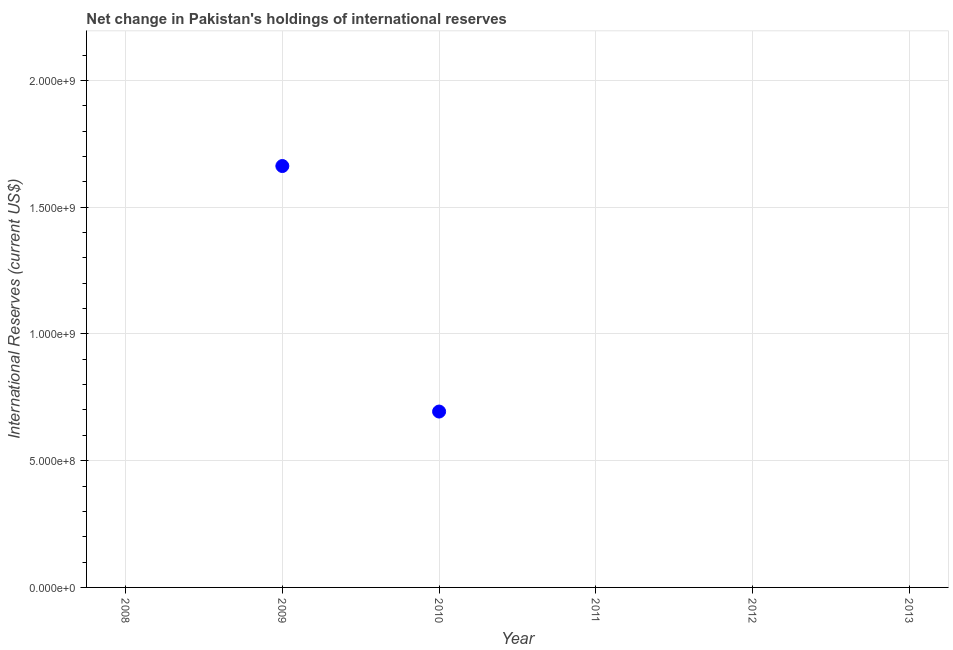What is the reserves and related items in 2009?
Provide a succinct answer. 1.66e+09. Across all years, what is the maximum reserves and related items?
Provide a short and direct response. 1.66e+09. What is the sum of the reserves and related items?
Offer a very short reply. 2.36e+09. What is the average reserves and related items per year?
Offer a very short reply. 3.93e+08. What is the median reserves and related items?
Your answer should be compact. 0. Is the reserves and related items in 2009 less than that in 2010?
Provide a succinct answer. No. What is the difference between the highest and the lowest reserves and related items?
Your response must be concise. 1.66e+09. How many years are there in the graph?
Offer a terse response. 6. Are the values on the major ticks of Y-axis written in scientific E-notation?
Provide a short and direct response. Yes. Does the graph contain any zero values?
Provide a short and direct response. Yes. What is the title of the graph?
Your answer should be very brief. Net change in Pakistan's holdings of international reserves. What is the label or title of the X-axis?
Your response must be concise. Year. What is the label or title of the Y-axis?
Your answer should be compact. International Reserves (current US$). What is the International Reserves (current US$) in 2008?
Your answer should be very brief. 0. What is the International Reserves (current US$) in 2009?
Make the answer very short. 1.66e+09. What is the International Reserves (current US$) in 2010?
Your answer should be very brief. 6.94e+08. What is the difference between the International Reserves (current US$) in 2009 and 2010?
Make the answer very short. 9.69e+08. What is the ratio of the International Reserves (current US$) in 2009 to that in 2010?
Ensure brevity in your answer.  2.4. 